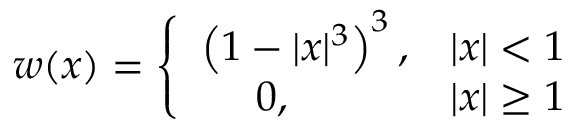Convert formula to latex. <formula><loc_0><loc_0><loc_500><loc_500>w ( x ) = \left \{ \begin{array} { l l } { \left ( 1 - | x | ^ { 3 } \right ) ^ { 3 } , } & { | x | < 1 } \\ { 0 , } & { | x | \geq 1 } \end{array}</formula> 